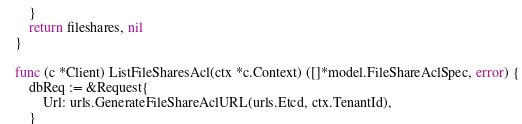<code> <loc_0><loc_0><loc_500><loc_500><_Go_>	}
	return fileshares, nil
}

func (c *Client) ListFileSharesAcl(ctx *c.Context) ([]*model.FileShareAclSpec, error) {
	dbReq := &Request{
		Url: urls.GenerateFileShareAclURL(urls.Etcd, ctx.TenantId),
	}
</code> 